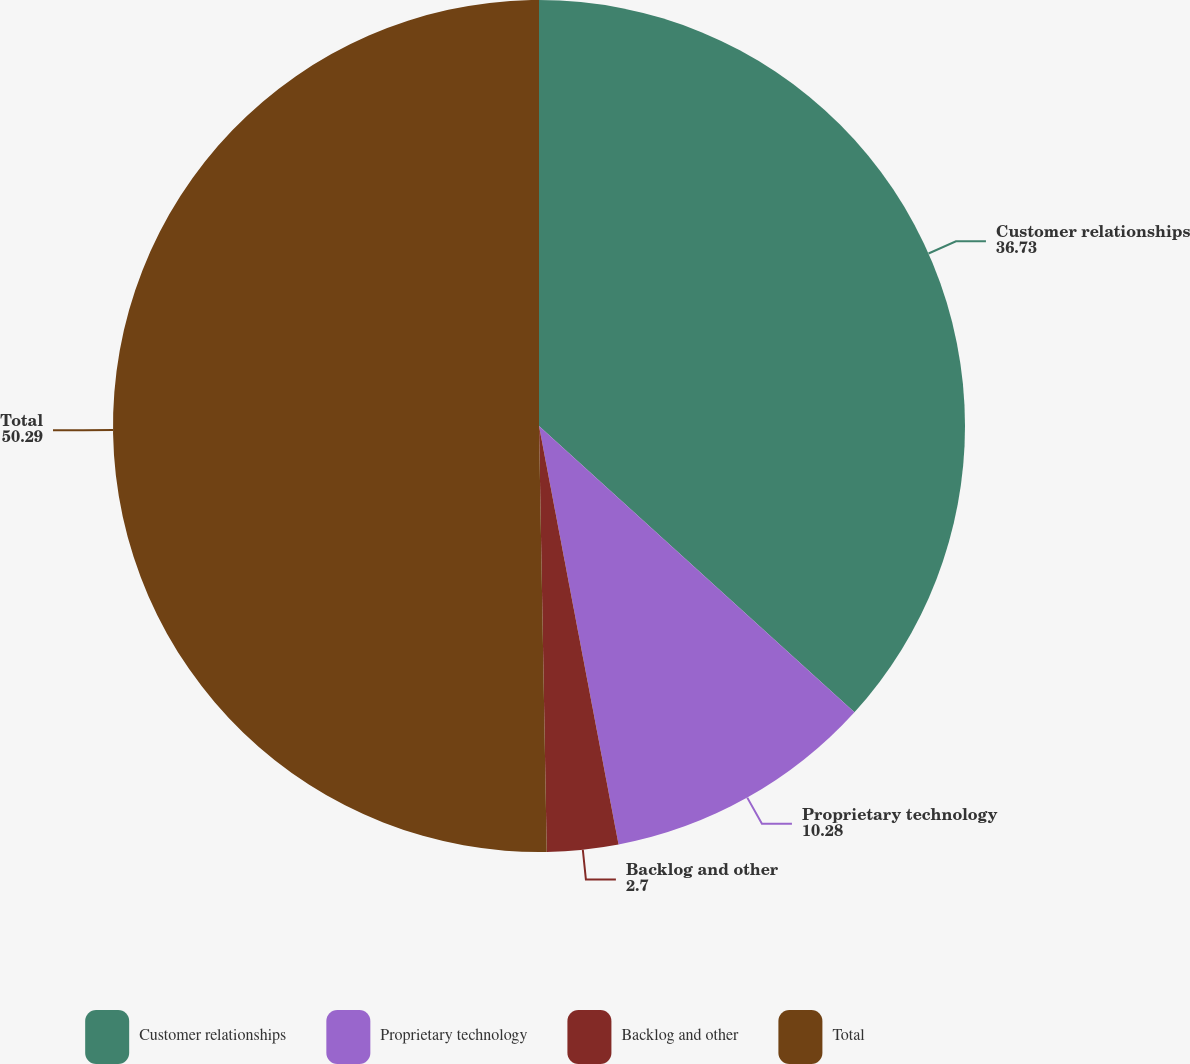<chart> <loc_0><loc_0><loc_500><loc_500><pie_chart><fcel>Customer relationships<fcel>Proprietary technology<fcel>Backlog and other<fcel>Total<nl><fcel>36.73%<fcel>10.28%<fcel>2.7%<fcel>50.29%<nl></chart> 